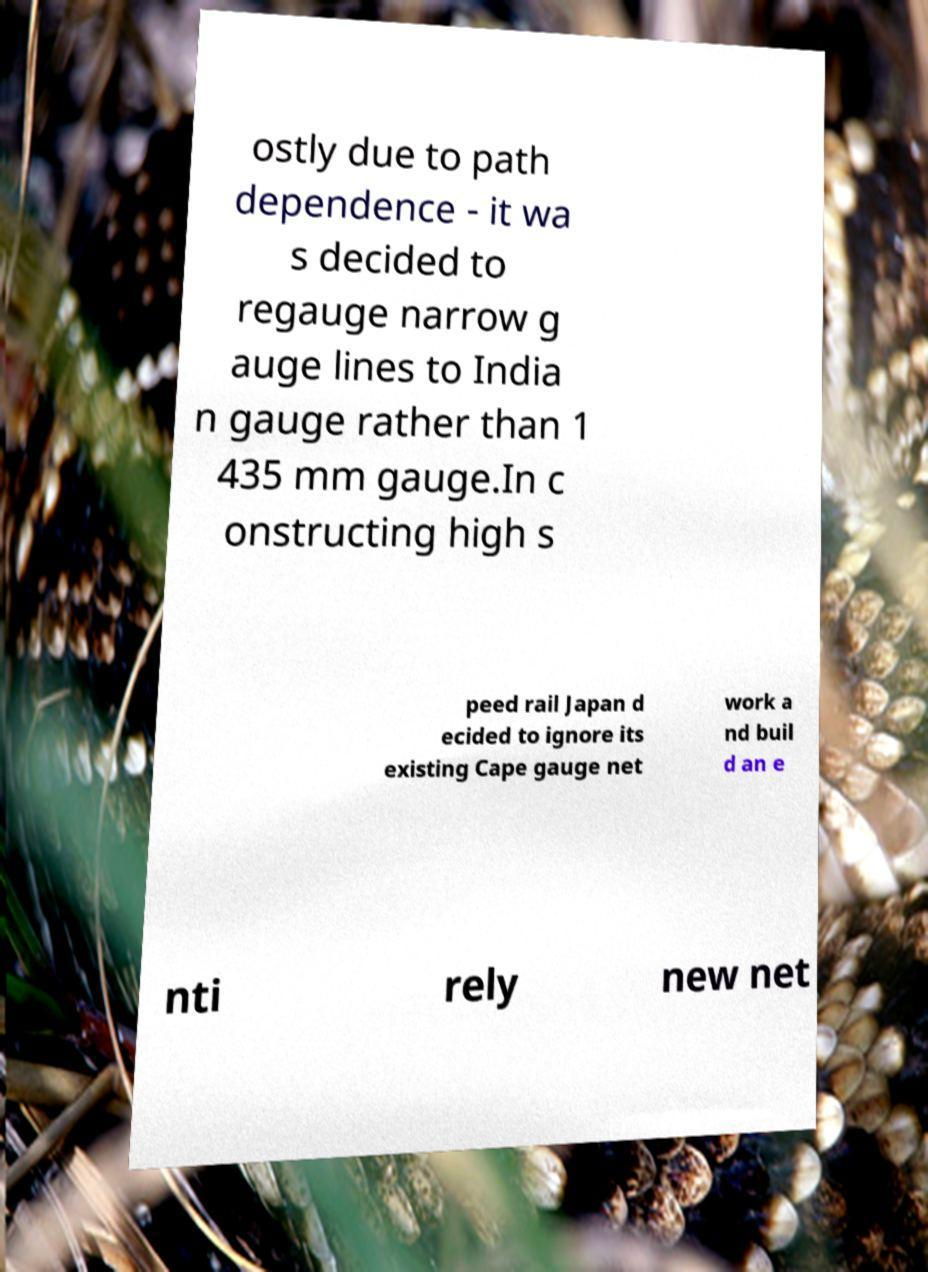I need the written content from this picture converted into text. Can you do that? ostly due to path dependence - it wa s decided to regauge narrow g auge lines to India n gauge rather than 1 435 mm gauge.In c onstructing high s peed rail Japan d ecided to ignore its existing Cape gauge net work a nd buil d an e nti rely new net 